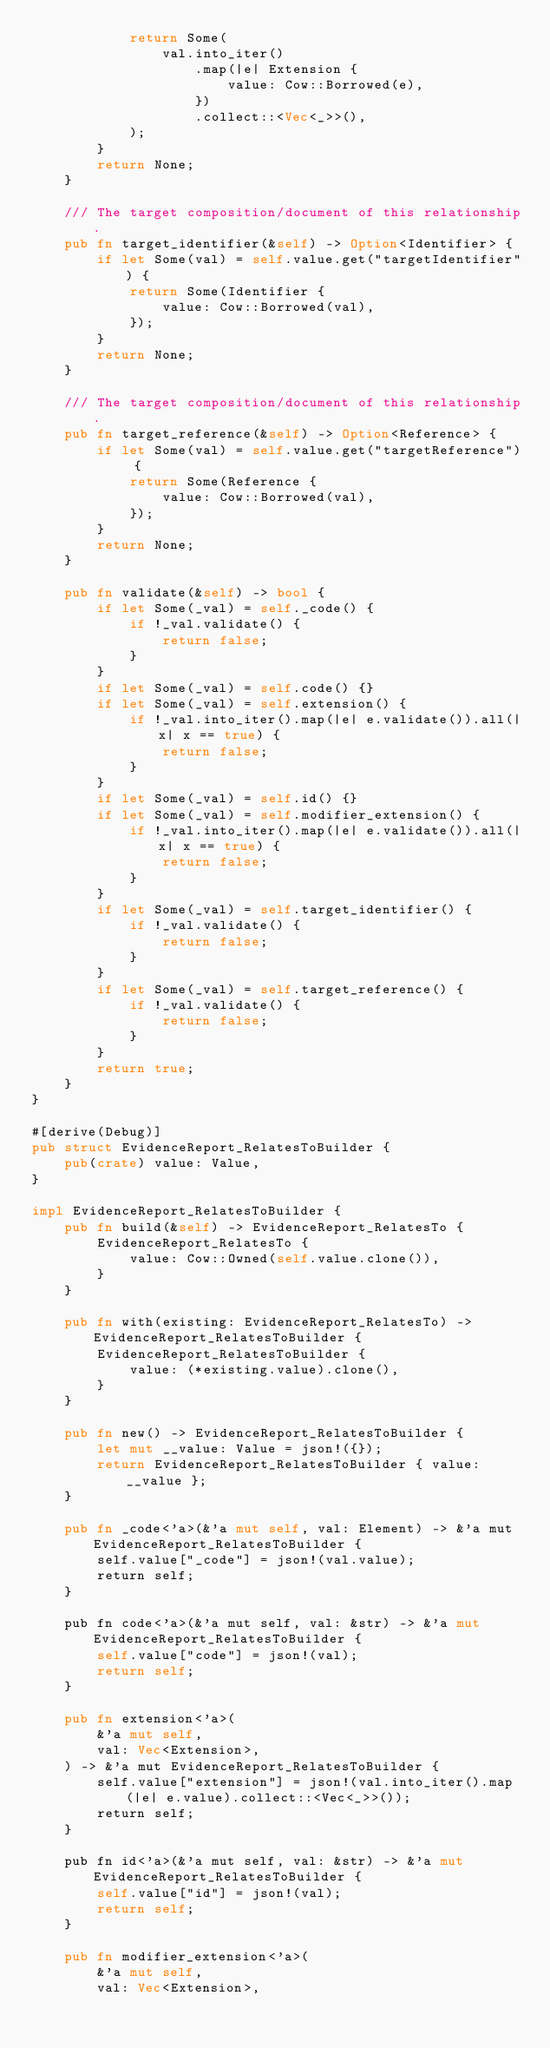Convert code to text. <code><loc_0><loc_0><loc_500><loc_500><_Rust_>            return Some(
                val.into_iter()
                    .map(|e| Extension {
                        value: Cow::Borrowed(e),
                    })
                    .collect::<Vec<_>>(),
            );
        }
        return None;
    }

    /// The target composition/document of this relationship.
    pub fn target_identifier(&self) -> Option<Identifier> {
        if let Some(val) = self.value.get("targetIdentifier") {
            return Some(Identifier {
                value: Cow::Borrowed(val),
            });
        }
        return None;
    }

    /// The target composition/document of this relationship.
    pub fn target_reference(&self) -> Option<Reference> {
        if let Some(val) = self.value.get("targetReference") {
            return Some(Reference {
                value: Cow::Borrowed(val),
            });
        }
        return None;
    }

    pub fn validate(&self) -> bool {
        if let Some(_val) = self._code() {
            if !_val.validate() {
                return false;
            }
        }
        if let Some(_val) = self.code() {}
        if let Some(_val) = self.extension() {
            if !_val.into_iter().map(|e| e.validate()).all(|x| x == true) {
                return false;
            }
        }
        if let Some(_val) = self.id() {}
        if let Some(_val) = self.modifier_extension() {
            if !_val.into_iter().map(|e| e.validate()).all(|x| x == true) {
                return false;
            }
        }
        if let Some(_val) = self.target_identifier() {
            if !_val.validate() {
                return false;
            }
        }
        if let Some(_val) = self.target_reference() {
            if !_val.validate() {
                return false;
            }
        }
        return true;
    }
}

#[derive(Debug)]
pub struct EvidenceReport_RelatesToBuilder {
    pub(crate) value: Value,
}

impl EvidenceReport_RelatesToBuilder {
    pub fn build(&self) -> EvidenceReport_RelatesTo {
        EvidenceReport_RelatesTo {
            value: Cow::Owned(self.value.clone()),
        }
    }

    pub fn with(existing: EvidenceReport_RelatesTo) -> EvidenceReport_RelatesToBuilder {
        EvidenceReport_RelatesToBuilder {
            value: (*existing.value).clone(),
        }
    }

    pub fn new() -> EvidenceReport_RelatesToBuilder {
        let mut __value: Value = json!({});
        return EvidenceReport_RelatesToBuilder { value: __value };
    }

    pub fn _code<'a>(&'a mut self, val: Element) -> &'a mut EvidenceReport_RelatesToBuilder {
        self.value["_code"] = json!(val.value);
        return self;
    }

    pub fn code<'a>(&'a mut self, val: &str) -> &'a mut EvidenceReport_RelatesToBuilder {
        self.value["code"] = json!(val);
        return self;
    }

    pub fn extension<'a>(
        &'a mut self,
        val: Vec<Extension>,
    ) -> &'a mut EvidenceReport_RelatesToBuilder {
        self.value["extension"] = json!(val.into_iter().map(|e| e.value).collect::<Vec<_>>());
        return self;
    }

    pub fn id<'a>(&'a mut self, val: &str) -> &'a mut EvidenceReport_RelatesToBuilder {
        self.value["id"] = json!(val);
        return self;
    }

    pub fn modifier_extension<'a>(
        &'a mut self,
        val: Vec<Extension>,</code> 